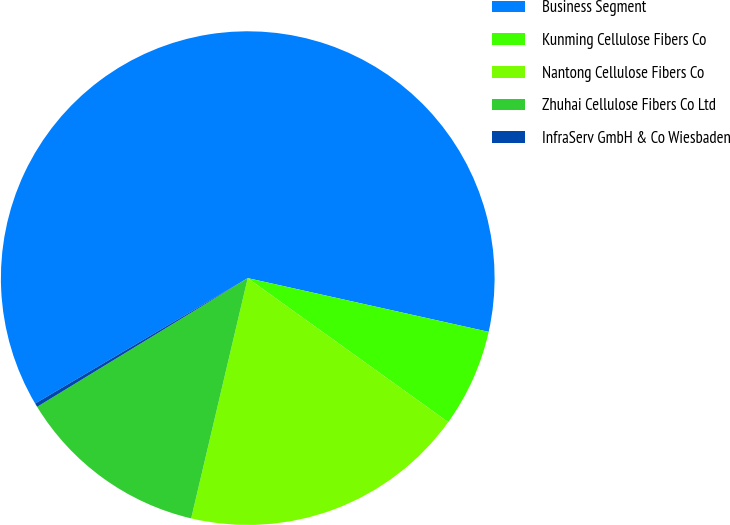Convert chart to OTSL. <chart><loc_0><loc_0><loc_500><loc_500><pie_chart><fcel>Business Segment<fcel>Kunming Cellulose Fibers Co<fcel>Nantong Cellulose Fibers Co<fcel>Zhuhai Cellulose Fibers Co Ltd<fcel>InfraServ GmbH & Co Wiesbaden<nl><fcel>61.98%<fcel>6.42%<fcel>18.77%<fcel>12.59%<fcel>0.25%<nl></chart> 